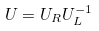Convert formula to latex. <formula><loc_0><loc_0><loc_500><loc_500>U = U _ { R } U _ { L } ^ { - 1 }</formula> 